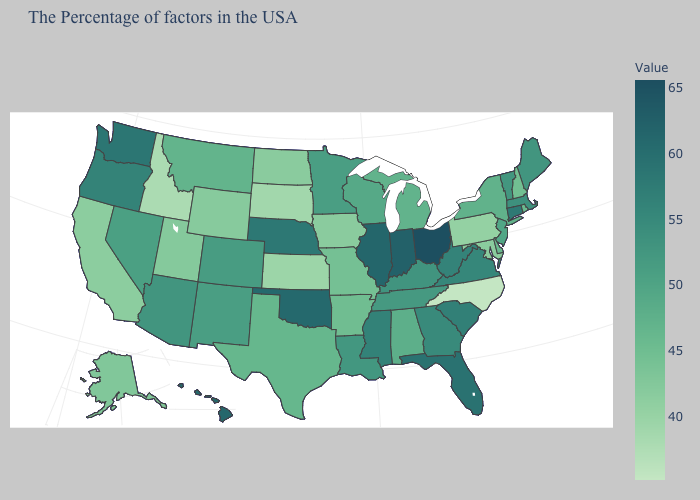Which states have the lowest value in the West?
Write a very short answer. Idaho. Among the states that border North Carolina , does Tennessee have the lowest value?
Write a very short answer. Yes. Does Alabama have a lower value than South Dakota?
Short answer required. No. Among the states that border Arkansas , which have the lowest value?
Write a very short answer. Missouri. Does the map have missing data?
Be succinct. No. Which states have the lowest value in the USA?
Short answer required. North Carolina. Does Utah have the highest value in the West?
Answer briefly. No. 